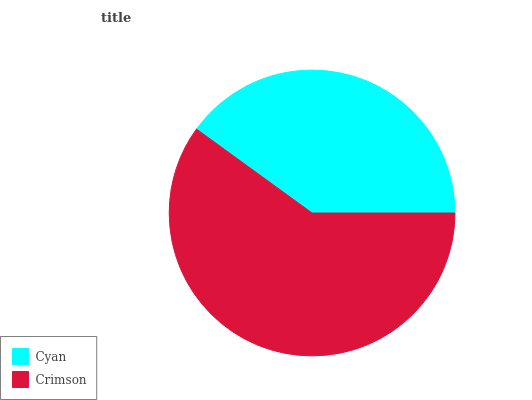Is Cyan the minimum?
Answer yes or no. Yes. Is Crimson the maximum?
Answer yes or no. Yes. Is Crimson the minimum?
Answer yes or no. No. Is Crimson greater than Cyan?
Answer yes or no. Yes. Is Cyan less than Crimson?
Answer yes or no. Yes. Is Cyan greater than Crimson?
Answer yes or no. No. Is Crimson less than Cyan?
Answer yes or no. No. Is Crimson the high median?
Answer yes or no. Yes. Is Cyan the low median?
Answer yes or no. Yes. Is Cyan the high median?
Answer yes or no. No. Is Crimson the low median?
Answer yes or no. No. 